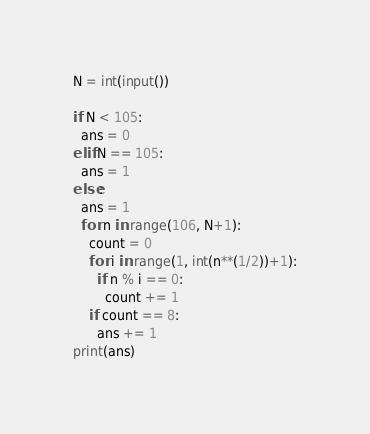Convert code to text. <code><loc_0><loc_0><loc_500><loc_500><_Python_>N = int(input())

if N < 105:
  ans = 0
elif N == 105:
  ans = 1
else:
  ans = 1
  for n in range(106, N+1):
    count = 0
    for i in range(1, int(n**(1/2))+1):
      if n % i == 0:
      	count += 1
    if count == 8:
      ans += 1
print(ans)</code> 